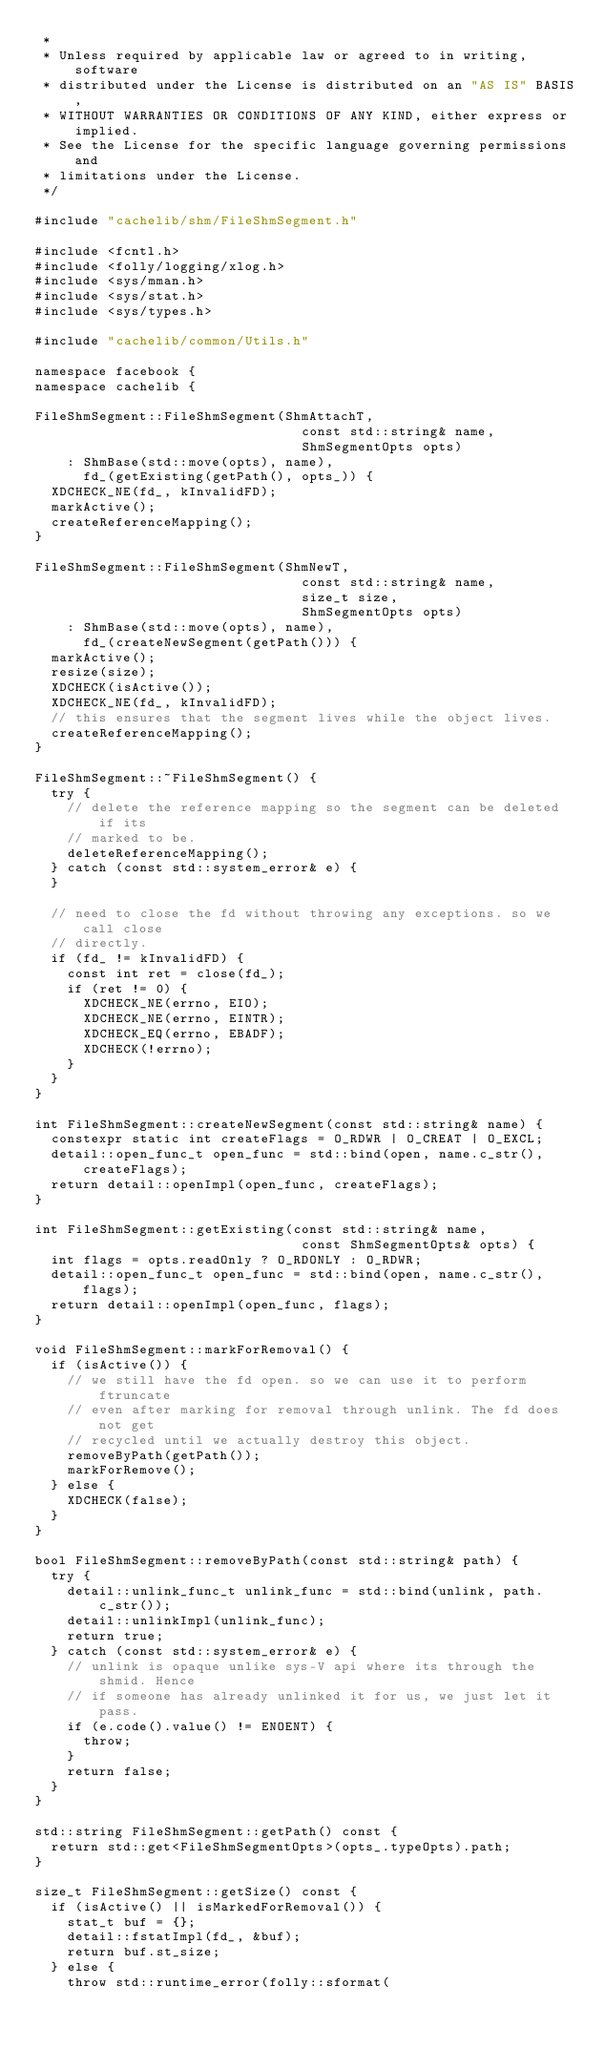Convert code to text. <code><loc_0><loc_0><loc_500><loc_500><_C++_> *
 * Unless required by applicable law or agreed to in writing, software
 * distributed under the License is distributed on an "AS IS" BASIS,
 * WITHOUT WARRANTIES OR CONDITIONS OF ANY KIND, either express or implied.
 * See the License for the specific language governing permissions and
 * limitations under the License.
 */

#include "cachelib/shm/FileShmSegment.h"

#include <fcntl.h>
#include <folly/logging/xlog.h>
#include <sys/mman.h>
#include <sys/stat.h>
#include <sys/types.h>

#include "cachelib/common/Utils.h"

namespace facebook {
namespace cachelib {

FileShmSegment::FileShmSegment(ShmAttachT,
                                 const std::string& name,
                                 ShmSegmentOpts opts)
    : ShmBase(std::move(opts), name),
      fd_(getExisting(getPath(), opts_)) {
  XDCHECK_NE(fd_, kInvalidFD);
  markActive();
  createReferenceMapping();
}

FileShmSegment::FileShmSegment(ShmNewT,
                                 const std::string& name,
                                 size_t size,
                                 ShmSegmentOpts opts)
    : ShmBase(std::move(opts), name),
      fd_(createNewSegment(getPath())) {
  markActive();
  resize(size);
  XDCHECK(isActive());
  XDCHECK_NE(fd_, kInvalidFD);
  // this ensures that the segment lives while the object lives.
  createReferenceMapping();
}

FileShmSegment::~FileShmSegment() {
  try {
    // delete the reference mapping so the segment can be deleted if its
    // marked to be.
    deleteReferenceMapping();
  } catch (const std::system_error& e) {
  }

  // need to close the fd without throwing any exceptions. so we call close
  // directly.
  if (fd_ != kInvalidFD) {
    const int ret = close(fd_);
    if (ret != 0) {
      XDCHECK_NE(errno, EIO);
      XDCHECK_NE(errno, EINTR);
      XDCHECK_EQ(errno, EBADF);
      XDCHECK(!errno);
    }
  }
}

int FileShmSegment::createNewSegment(const std::string& name) {
  constexpr static int createFlags = O_RDWR | O_CREAT | O_EXCL;
  detail::open_func_t open_func = std::bind(open, name.c_str(), createFlags);
  return detail::openImpl(open_func, createFlags);
}

int FileShmSegment::getExisting(const std::string& name,
                                 const ShmSegmentOpts& opts) {
  int flags = opts.readOnly ? O_RDONLY : O_RDWR;
  detail::open_func_t open_func = std::bind(open, name.c_str(), flags);
  return detail::openImpl(open_func, flags);
}

void FileShmSegment::markForRemoval() {
  if (isActive()) {
    // we still have the fd open. so we can use it to perform ftruncate
    // even after marking for removal through unlink. The fd does not get
    // recycled until we actually destroy this object.
    removeByPath(getPath());
    markForRemove();
  } else {
    XDCHECK(false);
  }
}

bool FileShmSegment::removeByPath(const std::string& path) {
  try {
    detail::unlink_func_t unlink_func = std::bind(unlink, path.c_str());
    detail::unlinkImpl(unlink_func);
    return true;
  } catch (const std::system_error& e) {
    // unlink is opaque unlike sys-V api where its through the shmid. Hence
    // if someone has already unlinked it for us, we just let it pass.
    if (e.code().value() != ENOENT) {
      throw;
    }
    return false;
  }
}

std::string FileShmSegment::getPath() const {
  return std::get<FileShmSegmentOpts>(opts_.typeOpts).path;
}

size_t FileShmSegment::getSize() const {
  if (isActive() || isMarkedForRemoval()) {
    stat_t buf = {};
    detail::fstatImpl(fd_, &buf);
    return buf.st_size;
  } else {
    throw std::runtime_error(folly::sformat(</code> 